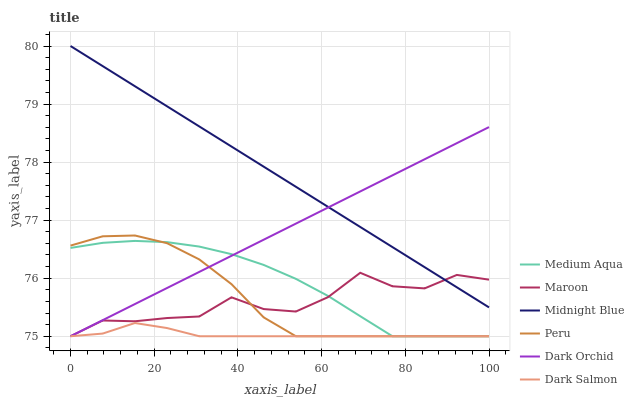Does Dark Orchid have the minimum area under the curve?
Answer yes or no. No. Does Dark Orchid have the maximum area under the curve?
Answer yes or no. No. Is Dark Salmon the smoothest?
Answer yes or no. No. Is Dark Salmon the roughest?
Answer yes or no. No. Does Dark Orchid have the highest value?
Answer yes or no. No. Is Dark Salmon less than Midnight Blue?
Answer yes or no. Yes. Is Midnight Blue greater than Peru?
Answer yes or no. Yes. Does Dark Salmon intersect Midnight Blue?
Answer yes or no. No. 